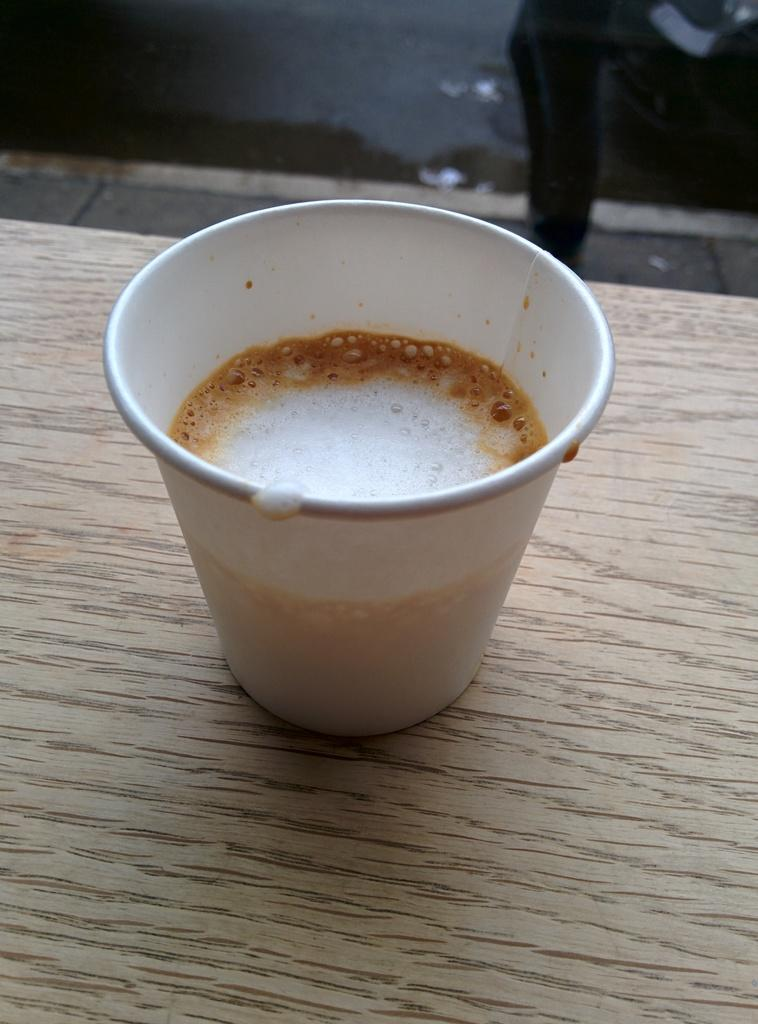What is in the cup that is visible in the image? There is a cup of coffee in the image. Where is the cup of coffee located in the image? The cup of coffee is placed on a table. What type of joke does the self-aware cup of coffee tell in the image? There is no indication that the cup of coffee is self-aware or capable of telling jokes in the image. 